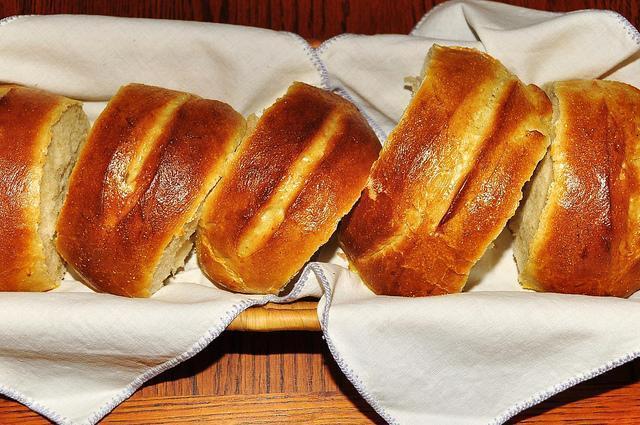How many pieces of bread are there?
Give a very brief answer. 5. How many hot dogs are there?
Give a very brief answer. 3. How many people are in the picture?
Give a very brief answer. 0. 